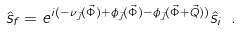<formula> <loc_0><loc_0><loc_500><loc_500>\hat { s } _ { f } = e ^ { i ( - \nu _ { \vec { J } } ( \vec { \Phi } ) + \phi _ { \vec { J } } ( \vec { \Phi } ) - \phi _ { \vec { J } } ( \vec { \Phi } + \vec { Q } ) ) } \hat { s } _ { i } \ .</formula> 